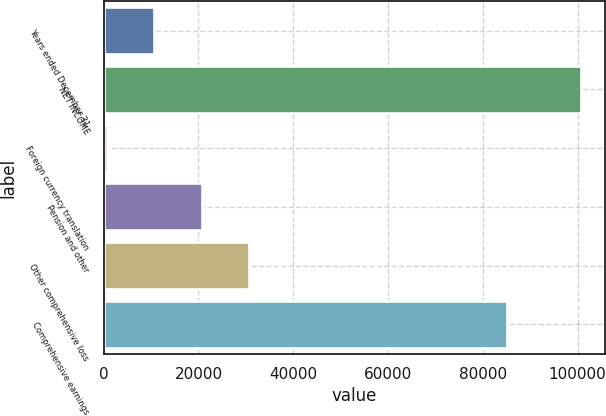<chart> <loc_0><loc_0><loc_500><loc_500><bar_chart><fcel>Years ended December 31<fcel>NET INCOME<fcel>Foreign currency translation<fcel>Pension and other<fcel>Other comprehensive loss<fcel>Comprehensive earnings<nl><fcel>10708.3<fcel>100711<fcel>708<fcel>20708.6<fcel>30708.9<fcel>85111<nl></chart> 